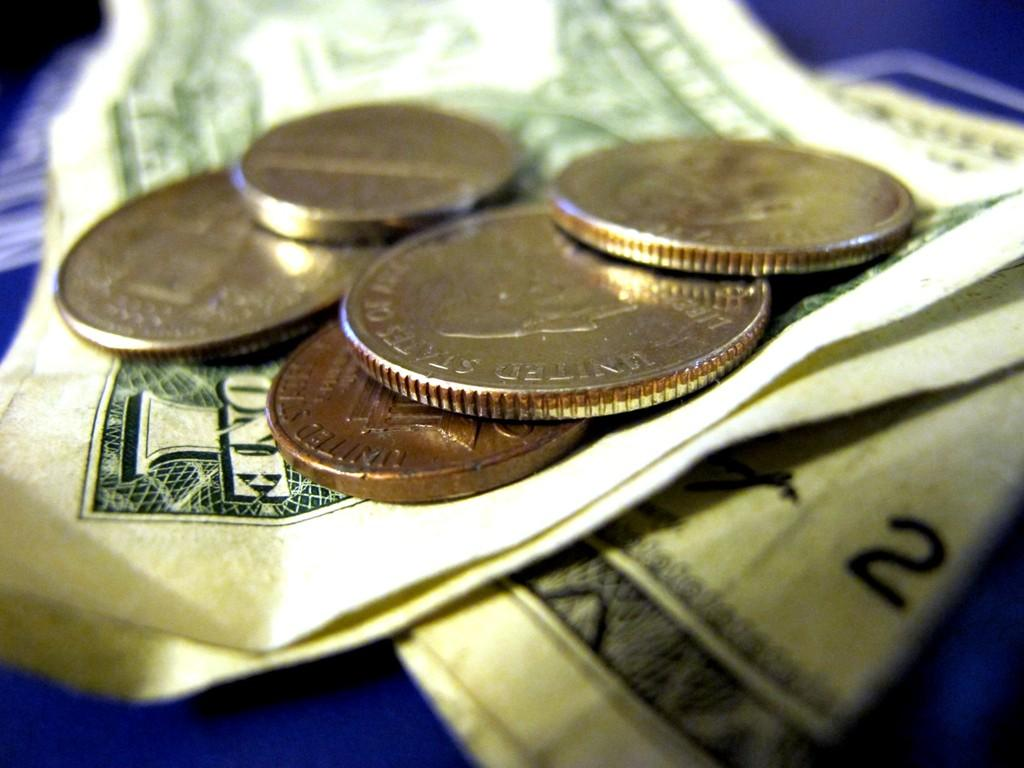<image>
Write a terse but informative summary of the picture. A pile of money from The United States of America sits on a blue table with a one dollar bill and many coins 